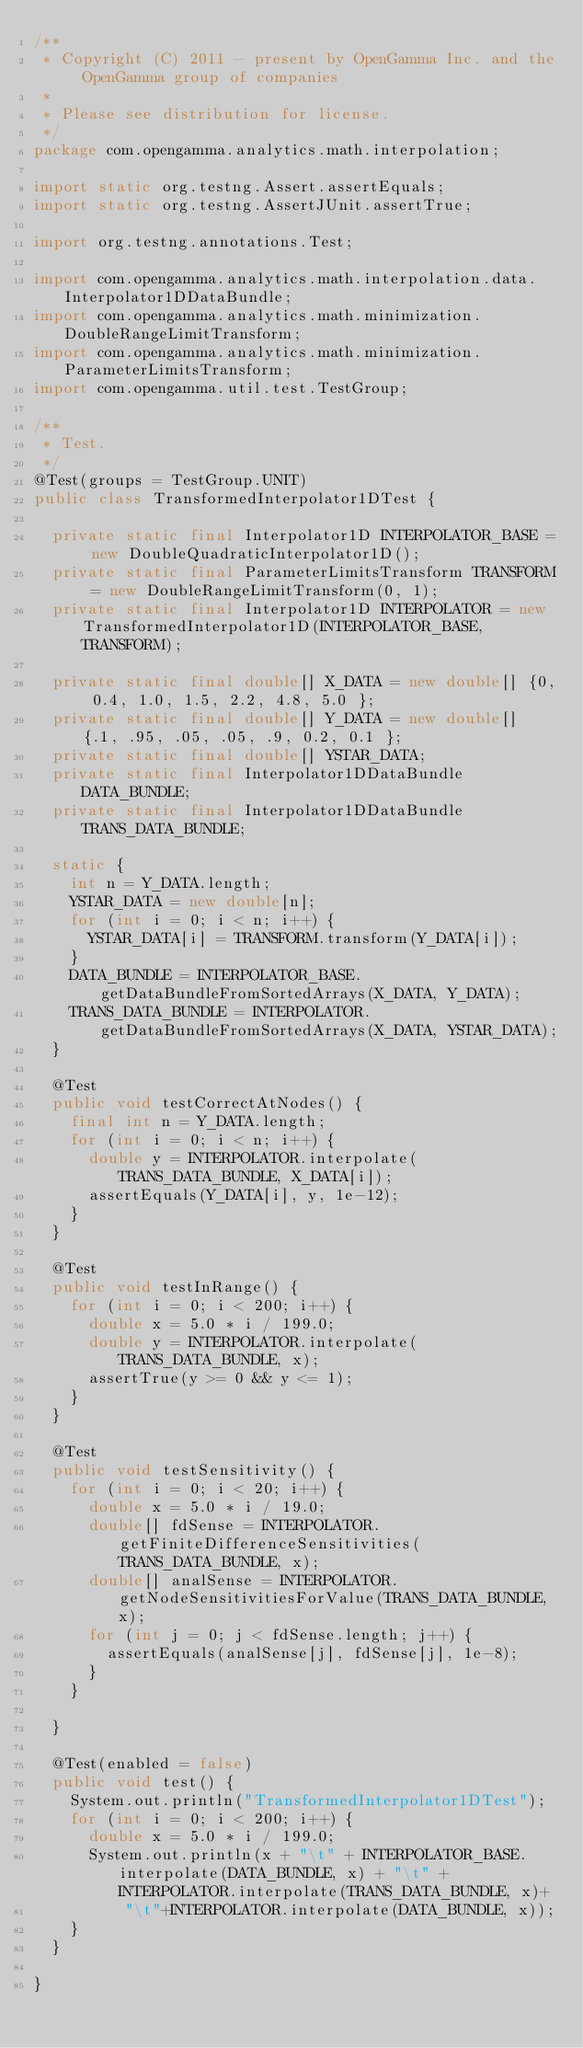<code> <loc_0><loc_0><loc_500><loc_500><_Java_>/**
 * Copyright (C) 2011 - present by OpenGamma Inc. and the OpenGamma group of companies
 * 
 * Please see distribution for license.
 */
package com.opengamma.analytics.math.interpolation;

import static org.testng.Assert.assertEquals;
import static org.testng.AssertJUnit.assertTrue;

import org.testng.annotations.Test;

import com.opengamma.analytics.math.interpolation.data.Interpolator1DDataBundle;
import com.opengamma.analytics.math.minimization.DoubleRangeLimitTransform;
import com.opengamma.analytics.math.minimization.ParameterLimitsTransform;
import com.opengamma.util.test.TestGroup;

/**
 * Test.
 */
@Test(groups = TestGroup.UNIT)
public class TransformedInterpolator1DTest {

  private static final Interpolator1D INTERPOLATOR_BASE = new DoubleQuadraticInterpolator1D();
  private static final ParameterLimitsTransform TRANSFORM = new DoubleRangeLimitTransform(0, 1);
  private static final Interpolator1D INTERPOLATOR = new TransformedInterpolator1D(INTERPOLATOR_BASE, TRANSFORM);

  private static final double[] X_DATA = new double[] {0, 0.4, 1.0, 1.5, 2.2, 4.8, 5.0 };
  private static final double[] Y_DATA = new double[] {.1, .95, .05, .05, .9, 0.2, 0.1 };
  private static final double[] YSTAR_DATA;
  private static final Interpolator1DDataBundle DATA_BUNDLE;
  private static final Interpolator1DDataBundle TRANS_DATA_BUNDLE;

  static {
    int n = Y_DATA.length;
    YSTAR_DATA = new double[n];
    for (int i = 0; i < n; i++) {
      YSTAR_DATA[i] = TRANSFORM.transform(Y_DATA[i]);
    }
    DATA_BUNDLE = INTERPOLATOR_BASE.getDataBundleFromSortedArrays(X_DATA, Y_DATA);
    TRANS_DATA_BUNDLE = INTERPOLATOR.getDataBundleFromSortedArrays(X_DATA, YSTAR_DATA);
  }

  @Test
  public void testCorrectAtNodes() {
    final int n = Y_DATA.length;
    for (int i = 0; i < n; i++) {
      double y = INTERPOLATOR.interpolate(TRANS_DATA_BUNDLE, X_DATA[i]);
      assertEquals(Y_DATA[i], y, 1e-12);
    }
  }

  @Test
  public void testInRange() {
    for (int i = 0; i < 200; i++) {
      double x = 5.0 * i / 199.0;
      double y = INTERPOLATOR.interpolate(TRANS_DATA_BUNDLE, x);
      assertTrue(y >= 0 && y <= 1);
    }
  }

  @Test
  public void testSensitivity() {
    for (int i = 0; i < 20; i++) {
      double x = 5.0 * i / 19.0;
      double[] fdSense = INTERPOLATOR.getFiniteDifferenceSensitivities(TRANS_DATA_BUNDLE, x);
      double[] analSense = INTERPOLATOR.getNodeSensitivitiesForValue(TRANS_DATA_BUNDLE, x);
      for (int j = 0; j < fdSense.length; j++) {
        assertEquals(analSense[j], fdSense[j], 1e-8);
      }
    }

  }

  @Test(enabled = false)
  public void test() {
    System.out.println("TransformedInterpolator1DTest");
    for (int i = 0; i < 200; i++) {
      double x = 5.0 * i / 199.0;
      System.out.println(x + "\t" + INTERPOLATOR_BASE.interpolate(DATA_BUNDLE, x) + "\t" + INTERPOLATOR.interpolate(TRANS_DATA_BUNDLE, x)+
          "\t"+INTERPOLATOR.interpolate(DATA_BUNDLE, x));
    }
  }

}
</code> 